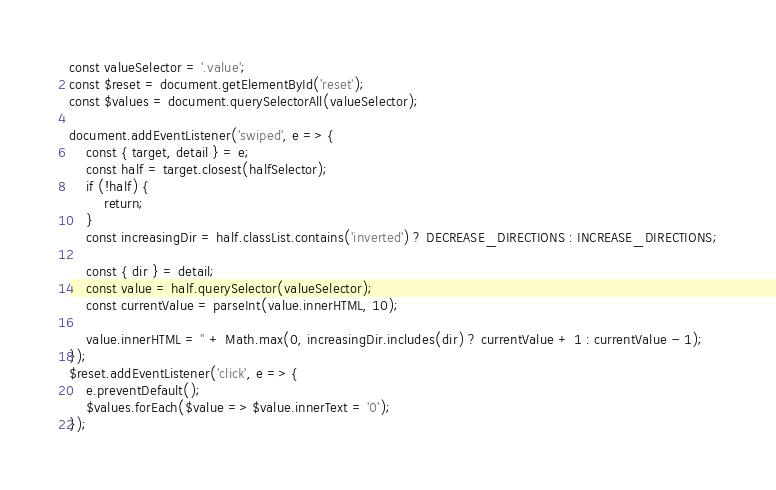Convert code to text. <code><loc_0><loc_0><loc_500><loc_500><_JavaScript_>const valueSelector = '.value';
const $reset = document.getElementById('reset');
const $values = document.querySelectorAll(valueSelector);

document.addEventListener('swiped', e => {
    const { target, detail } = e;
    const half = target.closest(halfSelector);
    if (!half) {
        return;
    }
    const increasingDir = half.classList.contains('inverted') ? DECREASE_DIRECTIONS : INCREASE_DIRECTIONS;

    const { dir } = detail;
    const value = half.querySelector(valueSelector);
    const currentValue = parseInt(value.innerHTML, 10);

    value.innerHTML = '' + Math.max(0, increasingDir.includes(dir) ? currentValue + 1 : currentValue - 1);
});
$reset.addEventListener('click', e => {
    e.preventDefault();
    $values.forEach($value => $value.innerText = '0');
});</code> 